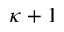Convert formula to latex. <formula><loc_0><loc_0><loc_500><loc_500>\kappa + 1</formula> 